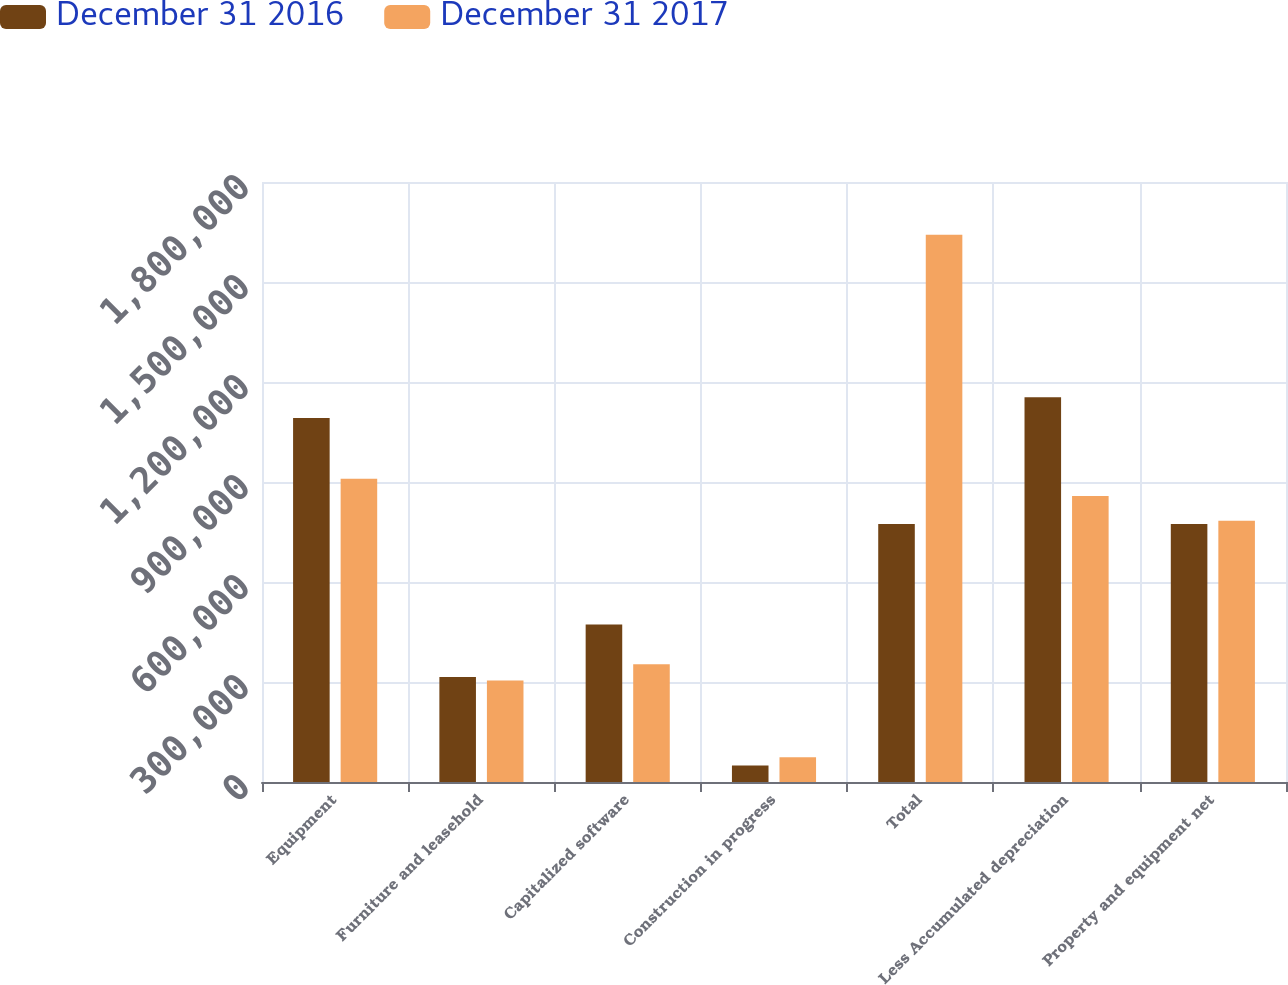Convert chart to OTSL. <chart><loc_0><loc_0><loc_500><loc_500><stacked_bar_chart><ecel><fcel>Equipment<fcel>Furniture and leasehold<fcel>Capitalized software<fcel>Construction in progress<fcel>Total<fcel>Less Accumulated depreciation<fcel>Property and equipment net<nl><fcel>December 31 2016<fcel>1.09167e+06<fcel>314852<fcel>472147<fcel>49417<fcel>773715<fcel>1.15437e+06<fcel>773715<nl><fcel>December 31 2017<fcel>909797<fcel>304613<fcel>353163<fcel>74255<fcel>1.64183e+06<fcel>857927<fcel>783901<nl></chart> 